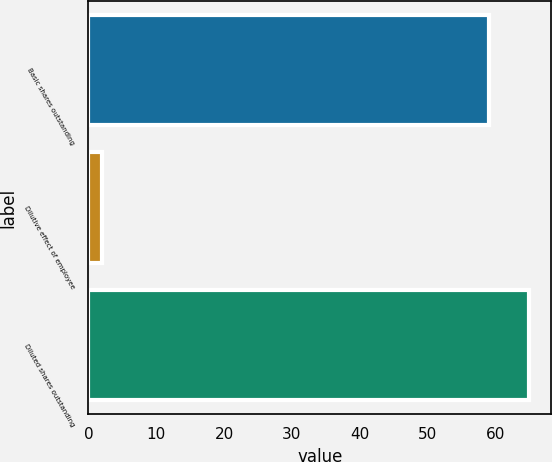<chart> <loc_0><loc_0><loc_500><loc_500><bar_chart><fcel>Basic shares outstanding<fcel>Dilutive effect of employee<fcel>Diluted shares outstanding<nl><fcel>59.1<fcel>2<fcel>65.01<nl></chart> 